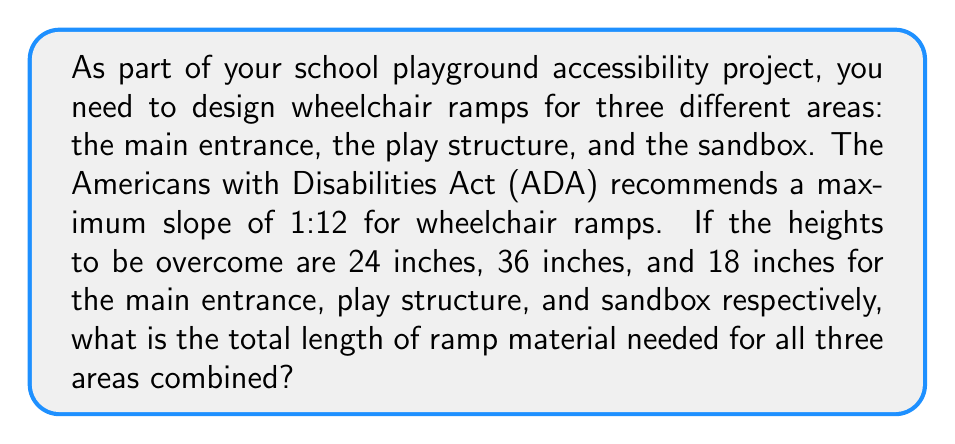Help me with this question. Let's approach this step-by-step:

1) The ADA recommendation of a 1:12 slope means that for every 1 inch of rise, we need 12 inches of ramp length.

2) For each area, we can calculate the required ramp length using the formula:
   $$ \text{Ramp Length} = \text{Height} \times 12 $$

3) Main entrance (24 inches height):
   $$ \text{Ramp Length}_1 = 24 \times 12 = 288 \text{ inches} $$

4) Play structure (36 inches height):
   $$ \text{Ramp Length}_2 = 36 \times 12 = 432 \text{ inches} $$

5) Sandbox (18 inches height):
   $$ \text{Ramp Length}_3 = 18 \times 12 = 216 \text{ inches} $$

6) Total length needed is the sum of all three ramp lengths:
   $$ \text{Total Length} = 288 + 432 + 216 = 936 \text{ inches} $$

7) Converting to feet for a more practical measurement:
   $$ \text{Total Length in Feet} = 936 \div 12 = 78 \text{ feet} $$
Answer: 78 feet 